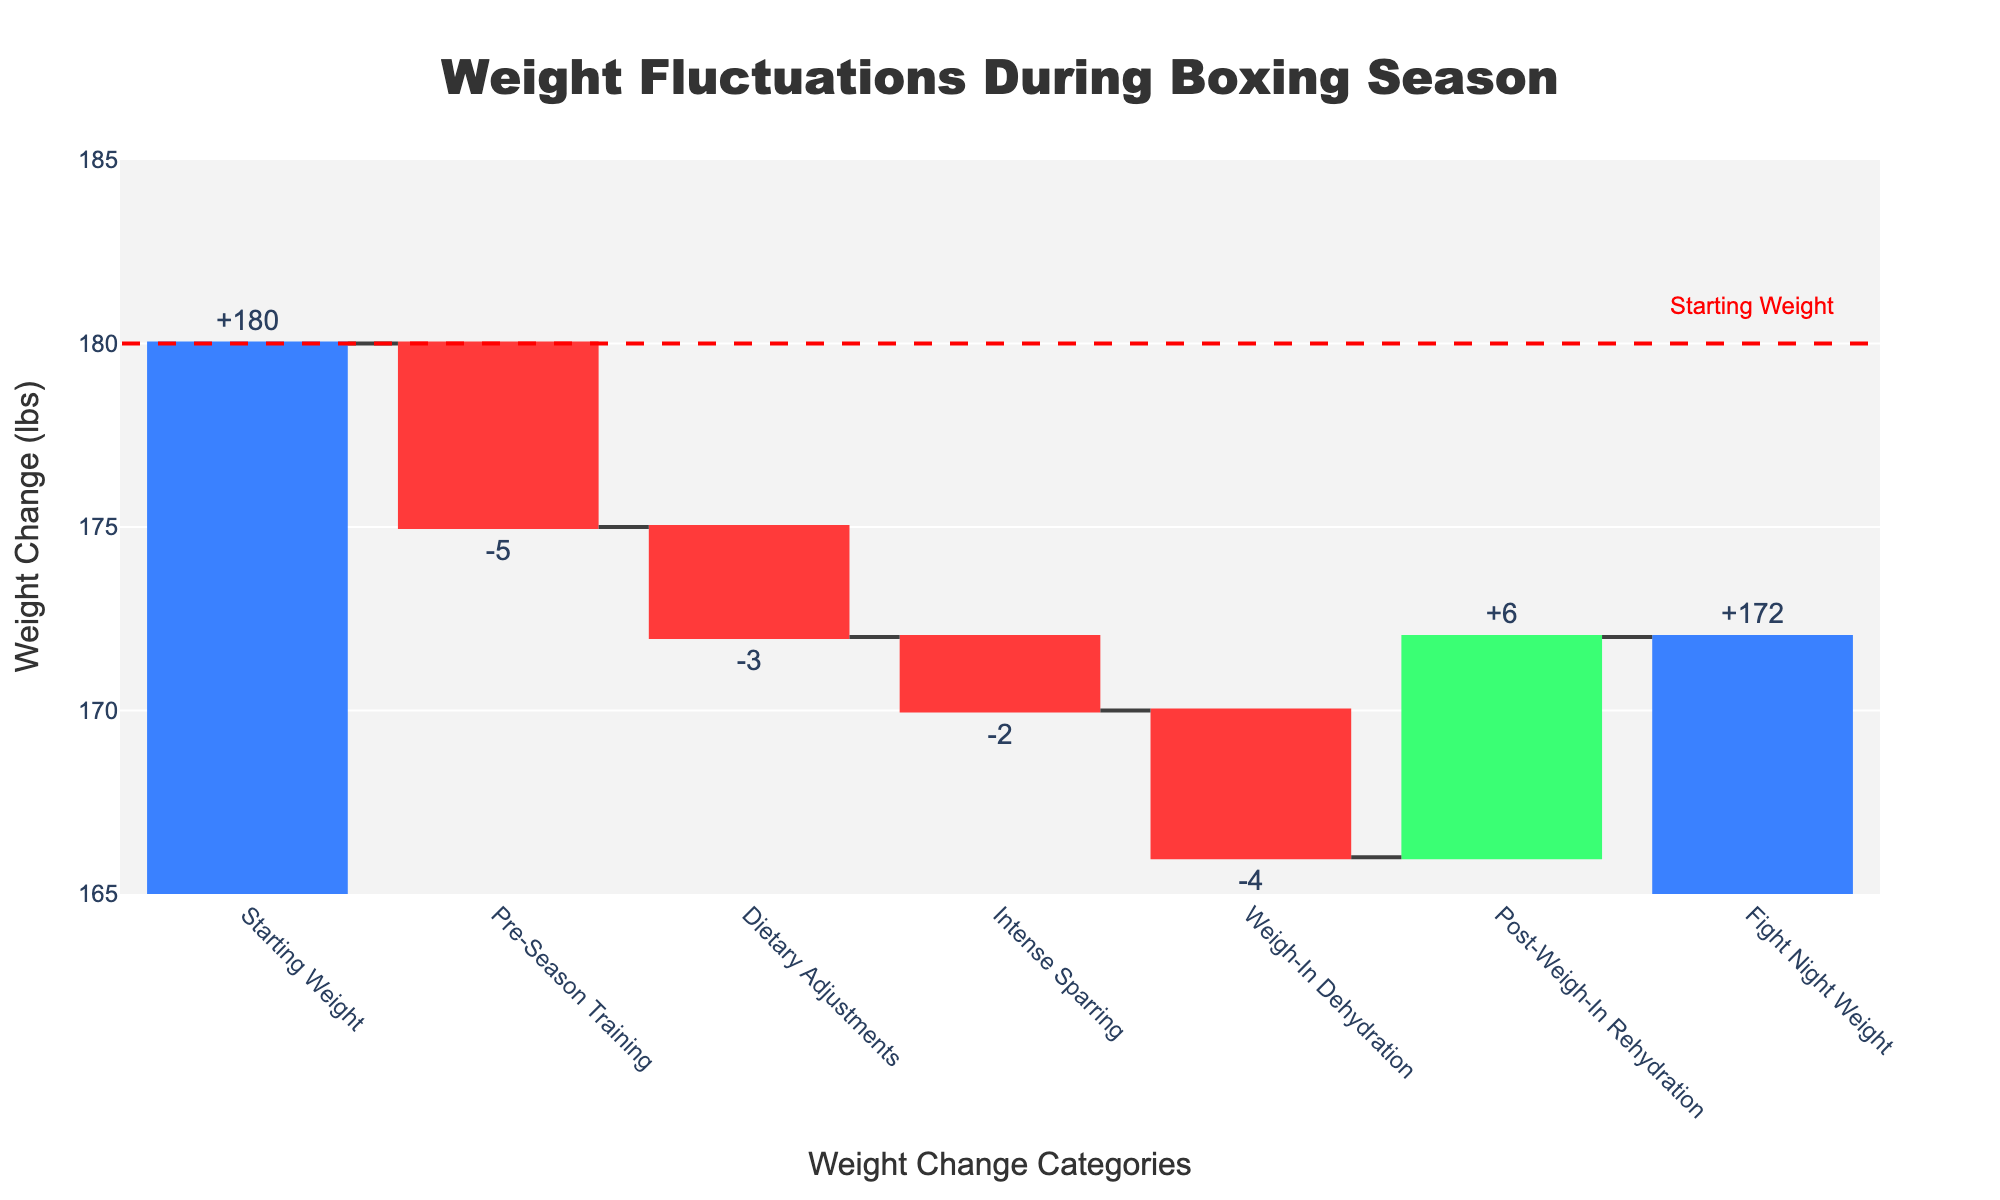What's the title of the figure? The title is located at the top of the figure and specifies what the chart represents.
Answer: Weight Fluctuations During Boxing Season What is the starting weight? The starting weight is marked as the first bar in the figure aligned to the y-axis value indicating the initial measurement.
Answer: 180 lbs How much weight did the boxer lose during pre-season training? The pre-season training weight change is marked as a decreasing bar directly labeled with the value on the figure.
Answer: 5 lbs What is the cumulative weight change after intense sparring? Add up the weight changes from starting weight, pre-season training, dietary adjustments, and intense sparring: 180 - 5 - 3 - 2 = 170 lbs.
Answer: 170 lbs Which weight change step resulted in the largest absolute weight change? Compare the magnitude of weight changes in the different categories; Post-Weigh-In Rehydration has the largest absolute value of +6 lbs.
Answer: Post-Weigh-In Rehydration What's the weight change during weigh-in dehydration? The weigh-in dehydration change is one of the descending bars labeled directly on the chart.
Answer: 4 lbs What is the final fight night weight? The final bar on the chart labeled "Fight Night Weight" shows the concluding weight after all changes.
Answer: 172 lbs How does the fight night weight compare to the starting weight? Compare the final bar value (fight night weight) to the initial bar value (starting weight): 172 lbs is less than 180 lbs indicating a drop.
Answer: 8 lbs lighter Which steps resulted in weight gain? Identify the steps marked with increasing weight (green bars): Post-Weigh-In Rehydration resulted in weight gain.
Answer: Post-Weigh-In Rehydration What was the cumulative weight loss before post-weigh-in rehydration? Starting with 180 lbs and applying losses up to before rehydration: 180 - 5 - 3 - 2 - 4 = 166 lbs.
Answer: 166 lbs 